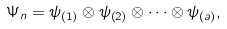Convert formula to latex. <formula><loc_0><loc_0><loc_500><loc_500>\Psi _ { n } = \psi _ { \left ( 1 \right ) } \otimes \psi _ { \left ( 2 \right ) } \otimes \dots \otimes \psi _ { \left ( a \right ) } ,</formula> 